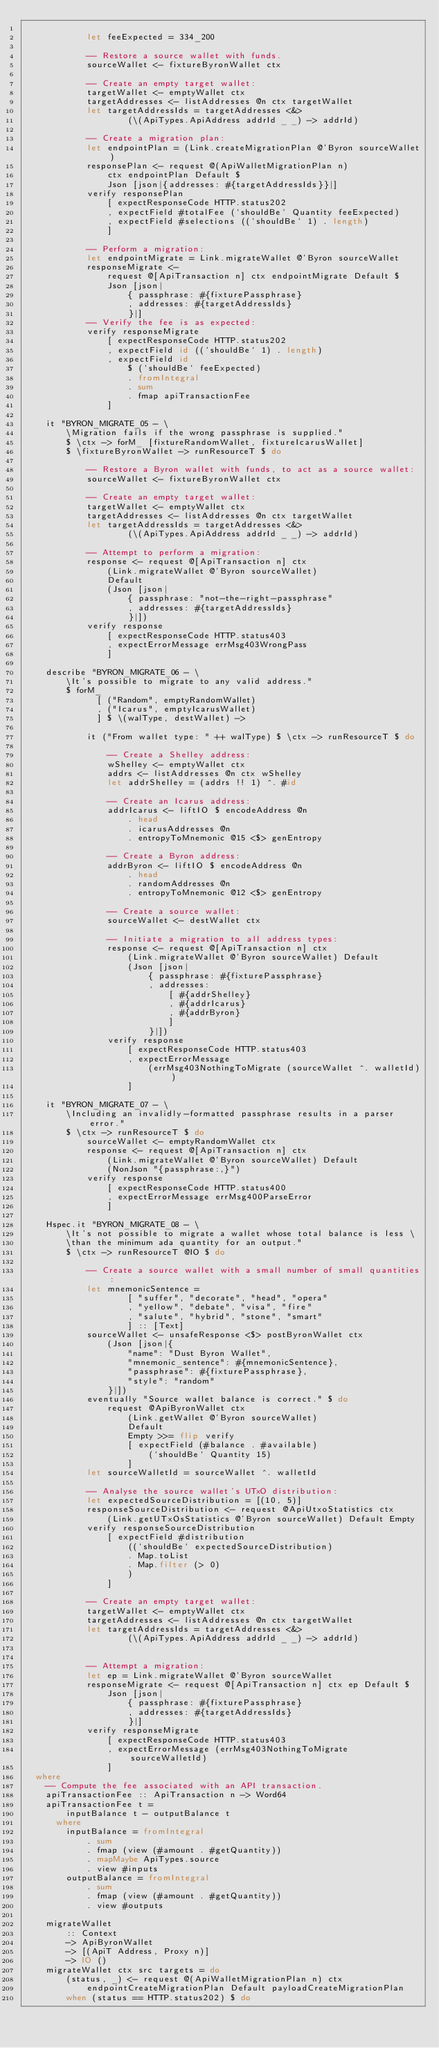Convert code to text. <code><loc_0><loc_0><loc_500><loc_500><_Haskell_>
            let feeExpected = 334_200

            -- Restore a source wallet with funds.
            sourceWallet <- fixtureByronWallet ctx

            -- Create an empty target wallet:
            targetWallet <- emptyWallet ctx
            targetAddresses <- listAddresses @n ctx targetWallet
            let targetAddressIds = targetAddresses <&>
                    (\(ApiTypes.ApiAddress addrId _ _) -> addrId)

            -- Create a migration plan:
            let endpointPlan = (Link.createMigrationPlan @'Byron sourceWallet)
            responsePlan <- request @(ApiWalletMigrationPlan n)
                ctx endpointPlan Default $
                Json [json|{addresses: #{targetAddressIds}}|]
            verify responsePlan
                [ expectResponseCode HTTP.status202
                , expectField #totalFee (`shouldBe` Quantity feeExpected)
                , expectField #selections ((`shouldBe` 1) . length)
                ]

            -- Perform a migration:
            let endpointMigrate = Link.migrateWallet @'Byron sourceWallet
            responseMigrate <-
                request @[ApiTransaction n] ctx endpointMigrate Default $
                Json [json|
                    { passphrase: #{fixturePassphrase}
                    , addresses: #{targetAddressIds}
                    }|]
            -- Verify the fee is as expected:
            verify responseMigrate
                [ expectResponseCode HTTP.status202
                , expectField id ((`shouldBe` 1) . length)
                , expectField id
                    $ (`shouldBe` feeExpected)
                    . fromIntegral
                    . sum
                    . fmap apiTransactionFee
                ]

    it "BYRON_MIGRATE_05 - \
        \Migration fails if the wrong passphrase is supplied."
        $ \ctx -> forM_ [fixtureRandomWallet, fixtureIcarusWallet]
        $ \fixtureByronWallet -> runResourceT $ do

            -- Restore a Byron wallet with funds, to act as a source wallet:
            sourceWallet <- fixtureByronWallet ctx

            -- Create an empty target wallet:
            targetWallet <- emptyWallet ctx
            targetAddresses <- listAddresses @n ctx targetWallet
            let targetAddressIds = targetAddresses <&>
                    (\(ApiTypes.ApiAddress addrId _ _) -> addrId)

            -- Attempt to perform a migration:
            response <- request @[ApiTransaction n] ctx
                (Link.migrateWallet @'Byron sourceWallet)
                Default
                (Json [json|
                    { passphrase: "not-the-right-passphrase"
                    , addresses: #{targetAddressIds}
                    }|])
            verify response
                [ expectResponseCode HTTP.status403
                , expectErrorMessage errMsg403WrongPass
                ]

    describe "BYRON_MIGRATE_06 - \
        \It's possible to migrate to any valid address."
        $ forM_
              [ ("Random", emptyRandomWallet)
              , ("Icarus", emptyIcarusWallet)
              ] $ \(walType, destWallet) ->

            it ("From wallet type: " ++ walType) $ \ctx -> runResourceT $ do

                -- Create a Shelley address:
                wShelley <- emptyWallet ctx
                addrs <- listAddresses @n ctx wShelley
                let addrShelley = (addrs !! 1) ^. #id

                -- Create an Icarus address:
                addrIcarus <- liftIO $ encodeAddress @n
                    . head
                    . icarusAddresses @n
                    . entropyToMnemonic @15 <$> genEntropy

                -- Create a Byron address:
                addrByron <- liftIO $ encodeAddress @n
                    . head
                    . randomAddresses @n
                    . entropyToMnemonic @12 <$> genEntropy

                -- Create a source wallet:
                sourceWallet <- destWallet ctx

                -- Initiate a migration to all address types:
                response <- request @[ApiTransaction n] ctx
                    (Link.migrateWallet @'Byron sourceWallet) Default
                    (Json [json|
                        { passphrase: #{fixturePassphrase}
                        , addresses:
                            [ #{addrShelley}
                            , #{addrIcarus}
                            , #{addrByron}
                            ]
                        }|])
                verify response
                    [ expectResponseCode HTTP.status403
                    , expectErrorMessage
                        (errMsg403NothingToMigrate (sourceWallet ^. walletId))
                    ]

    it "BYRON_MIGRATE_07 - \
        \Including an invalidly-formatted passphrase results in a parser error."
        $ \ctx -> runResourceT $ do
            sourceWallet <- emptyRandomWallet ctx
            response <- request @[ApiTransaction n] ctx
                (Link.migrateWallet @'Byron sourceWallet) Default
                (NonJson "{passphrase:,}")
            verify response
                [ expectResponseCode HTTP.status400
                , expectErrorMessage errMsg400ParseError
                ]

    Hspec.it "BYRON_MIGRATE_08 - \
        \It's not possible to migrate a wallet whose total balance is less \
        \than the minimum ada quantity for an output."
        $ \ctx -> runResourceT @IO $ do

            -- Create a source wallet with a small number of small quantities:
            let mnemonicSentence =
                    [ "suffer", "decorate", "head", "opera"
                    , "yellow", "debate", "visa", "fire"
                    , "salute", "hybrid", "stone", "smart"
                    ] :: [Text]
            sourceWallet <- unsafeResponse <$> postByronWallet ctx
                (Json [json|{
                    "name": "Dust Byron Wallet",
                    "mnemonic_sentence": #{mnemonicSentence},
                    "passphrase": #{fixturePassphrase},
                    "style": "random"
                }|])
            eventually "Source wallet balance is correct." $ do
                request @ApiByronWallet ctx
                    (Link.getWallet @'Byron sourceWallet)
                    Default
                    Empty >>= flip verify
                    [ expectField (#balance . #available)
                        (`shouldBe` Quantity 15)
                    ]
            let sourceWalletId = sourceWallet ^. walletId

            -- Analyse the source wallet's UTxO distribution:
            let expectedSourceDistribution = [(10, 5)]
            responseSourceDistribution <- request @ApiUtxoStatistics ctx
                (Link.getUTxOsStatistics @'Byron sourceWallet) Default Empty
            verify responseSourceDistribution
                [ expectField #distribution
                    ((`shouldBe` expectedSourceDistribution)
                    . Map.toList
                    . Map.filter (> 0)
                    )
                ]

            -- Create an empty target wallet:
            targetWallet <- emptyWallet ctx
            targetAddresses <- listAddresses @n ctx targetWallet
            let targetAddressIds = targetAddresses <&>
                    (\(ApiTypes.ApiAddress addrId _ _) -> addrId)


            -- Attempt a migration:
            let ep = Link.migrateWallet @'Byron sourceWallet
            responseMigrate <- request @[ApiTransaction n] ctx ep Default $
                Json [json|
                    { passphrase: #{fixturePassphrase}
                    , addresses: #{targetAddressIds}
                    }|]
            verify responseMigrate
                [ expectResponseCode HTTP.status403
                , expectErrorMessage (errMsg403NothingToMigrate sourceWalletId)
                ]
  where
    -- Compute the fee associated with an API transaction.
    apiTransactionFee :: ApiTransaction n -> Word64
    apiTransactionFee t =
        inputBalance t - outputBalance t
      where
        inputBalance = fromIntegral
            . sum
            . fmap (view (#amount . #getQuantity))
            . mapMaybe ApiTypes.source
            . view #inputs
        outputBalance = fromIntegral
            . sum
            . fmap (view (#amount . #getQuantity))
            . view #outputs

    migrateWallet
        :: Context
        -> ApiByronWallet
        -> [(ApiT Address, Proxy n)]
        -> IO ()
    migrateWallet ctx src targets = do
        (status, _) <- request @(ApiWalletMigrationPlan n) ctx
            endpointCreateMigrationPlan Default payloadCreateMigrationPlan
        when (status == HTTP.status202) $ do</code> 